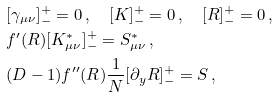<formula> <loc_0><loc_0><loc_500><loc_500>& [ \gamma _ { \mu \nu } ] ^ { + } _ { - } = 0 \, , \quad [ K ] ^ { + } _ { - } = 0 \, , \quad [ R ] ^ { + } _ { - } = 0 \, , \\ & f ^ { \prime } ( R ) [ K ^ { * } _ { \mu \nu } ] ^ { + } _ { - } = S ^ { * } _ { \mu \nu } \, , \\ & ( D - 1 ) f ^ { \prime \prime } ( R ) \frac { 1 } { N } [ \partial _ { y } R ] ^ { + } _ { - } = S \, ,</formula> 